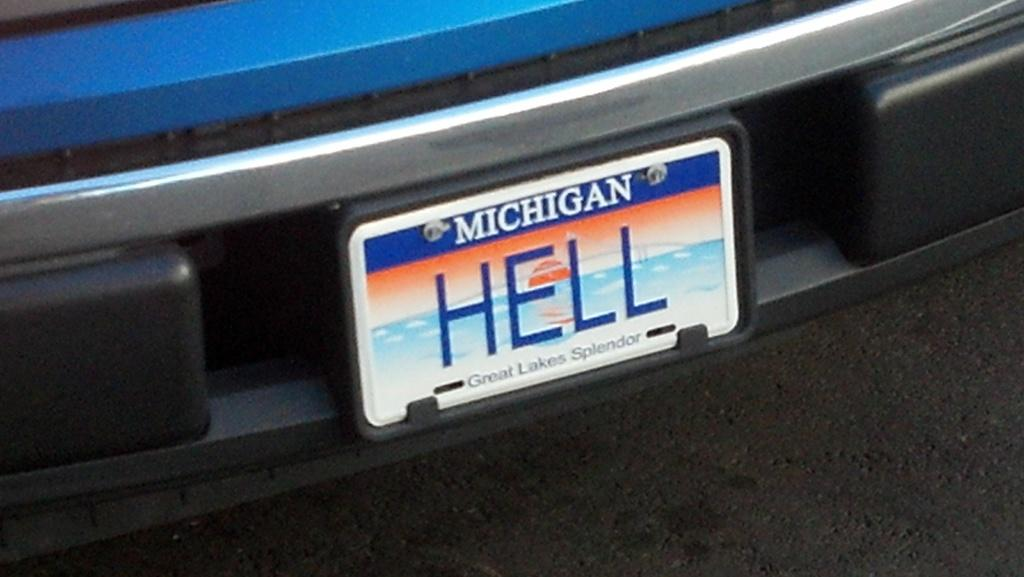<image>
Present a compact description of the photo's key features. A car has a Michigan license plate that says HELL. 